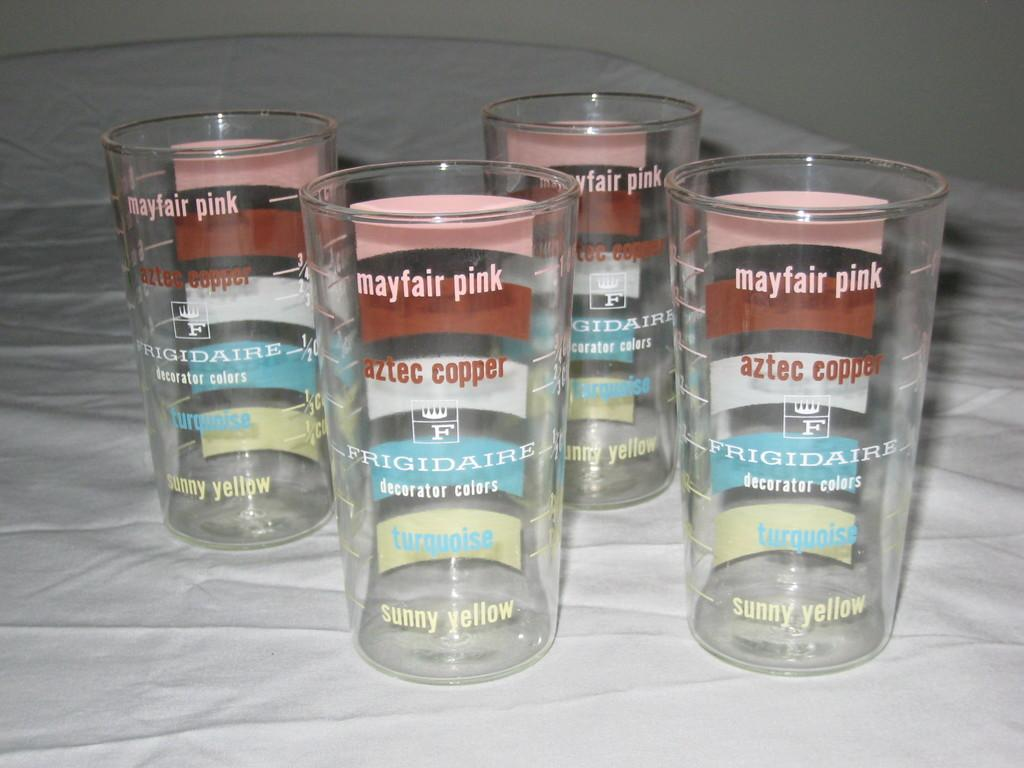<image>
Describe the image concisely. Four drink glasses with Frigidaire decorator colors as striped sections 